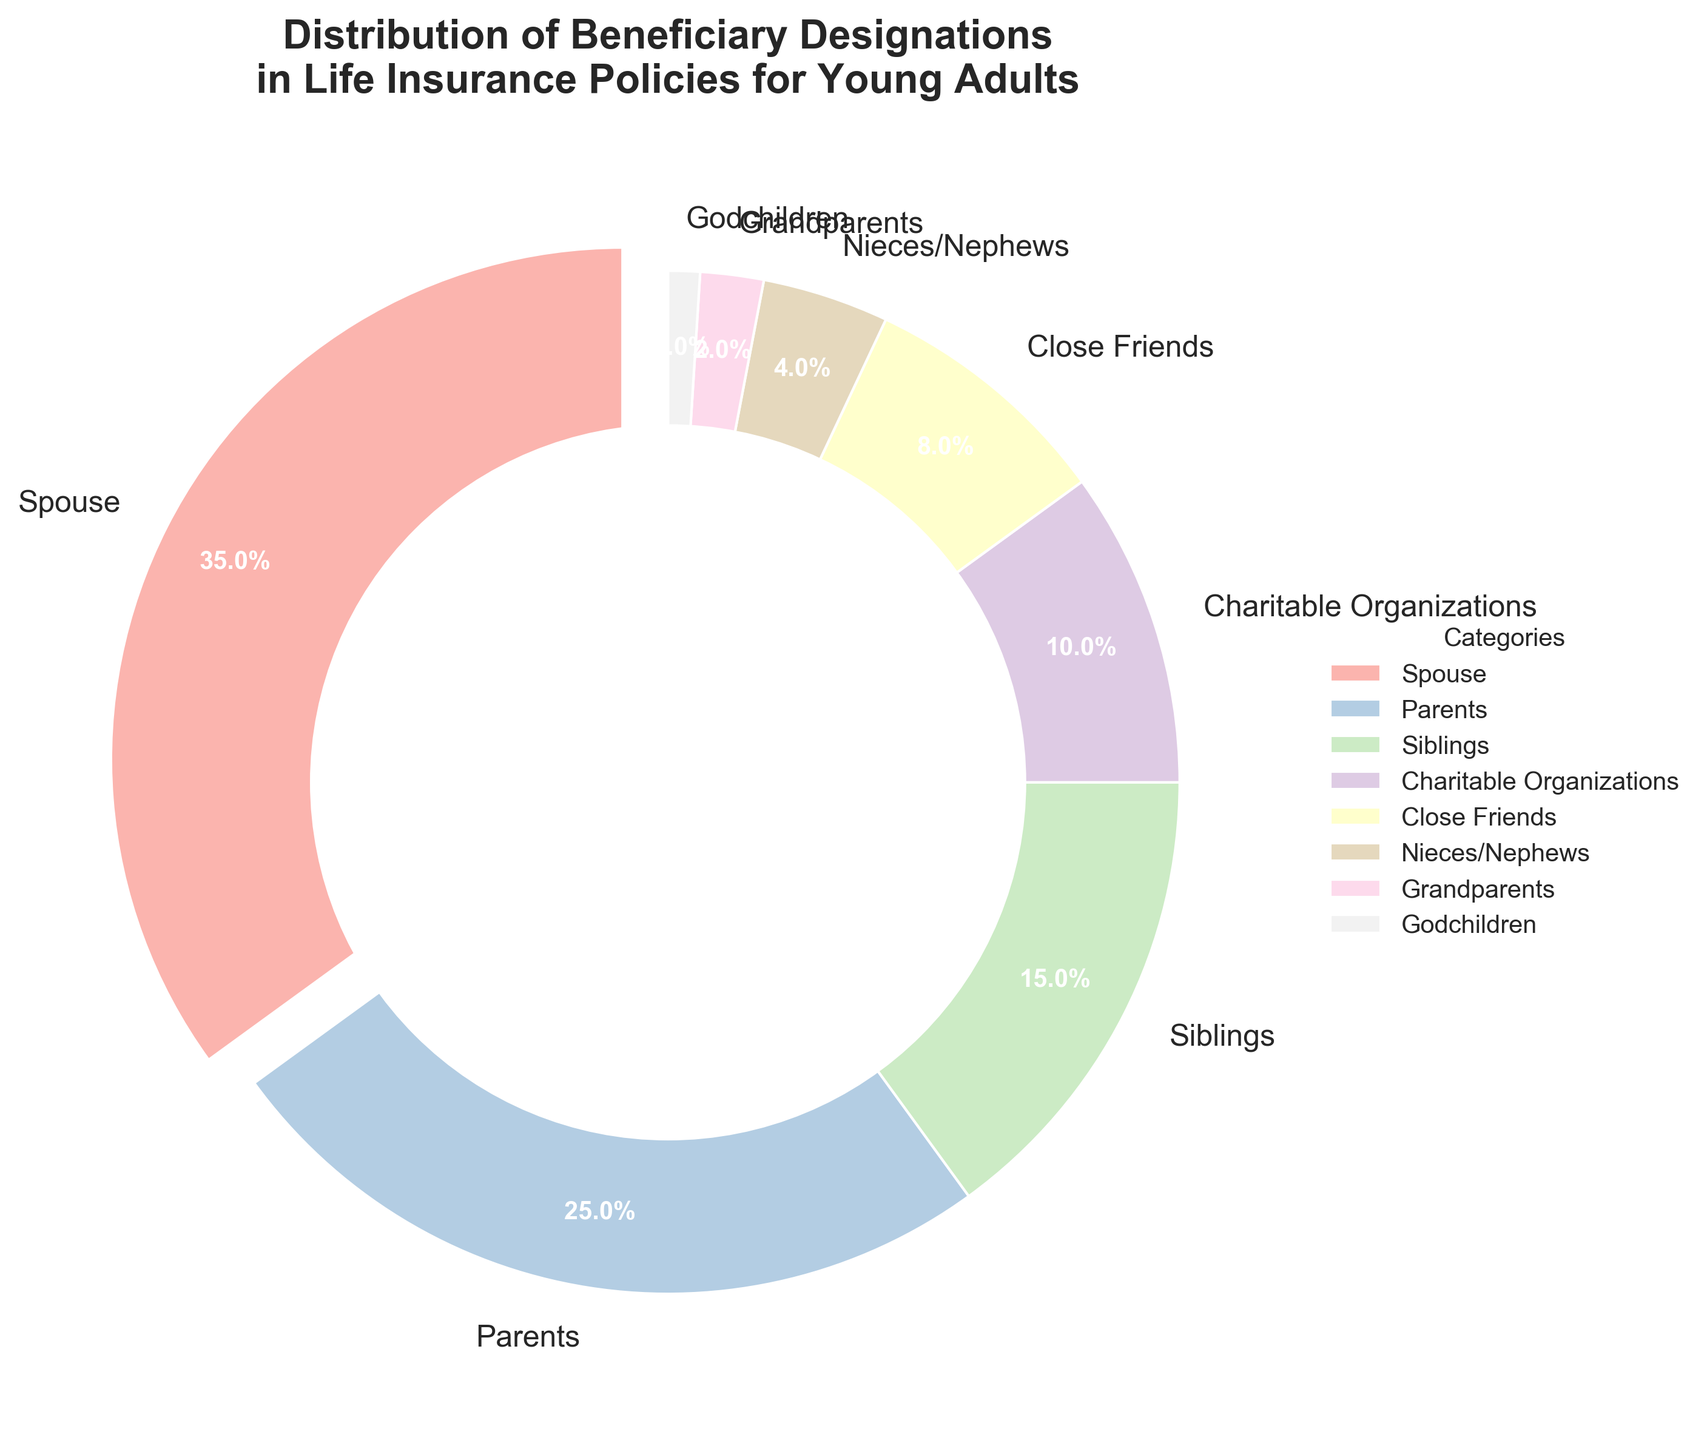What is the largest beneficiary designation category in the chart? The largest beneficiary category is the one with the highest percentage shown in the chart, which is the "Spouse" category with 35%.
Answer: Spouse Which category has a smaller percentage, Close Friends or Nieces/Nephews? To determine which category has a smaller percentage, we compare the percentage values. Close Friends have 8%, whereas Nieces/Nephews have only 4%. Therefore, Nieces/Nephews have a smaller percentage.
Answer: Nieces/Nephews How much higher is the percentage of Spouses compared to Parents? The percentage for Spouses is 35% and for Parents is 25%. Subtracting these two values gives 35% - 25% = 10%. So, the percentage for Spouses is 10% higher than for Parents.
Answer: 10% Which beneficiary categories combined make up exactly half of the total percentage? Adding up the percentages of Spouse (35%) and Parents (25%) gives 35% + 25% = 60%. This is more than half. Let's try Spouse (35%) and Siblings (15%): 35% + 15% = 50%. Therefore, Spouse and Siblings combined make up exactly 50%.
Answer: Spouse and Siblings What percentage of beneficiaries are grouped into family categories (Spouse, Parents, Siblings, Nieces/Nephews, Grandparents)? Summing up the percentages of Spouse (35%), Parents (25%), Siblings (15%), Nieces/Nephews (4%), and Grandparents (2%) gives 35% + 25% + 15% + 4% + 2% = 81%.
Answer: 81% Which category is represented by a section that is exploded or pulled out in the pie chart, and why? The exploded section is often used to highlight the largest category. In this chart, the Spouse category (35%) is the largest and therefore is the one that is exploded or pulled out.
Answer: Spouse What is the total combined percentage of beneficiaries designated to non-family categories (Charitable Organizations, Close Friends, Godchildren)? Adding the percentages of Charitable Organizations (10%), Close Friends (8%), and Godchildren (1%) gives a total of 10% + 8% + 1% = 19%.
Answer: 19% How much more is the percentage of parents compared to charitable organizations? The percentage for Parents is 25% and for Charitable Organizations is 10%. The difference is 25% - 10% = 15%.
Answer: 15% What is the percentage difference between the largest and smallest beneficiary designation categories? The largest category, Spouse, has 35%, and the smallest category, Godchildren, has 1%. So the difference is 35% - 1% = 34%.
Answer: 34% If you were to combine the percentages for siblings and grandparents, would it be greater than or less than the percentage for parents? The sum of the percentages for Siblings (15%) and Grandparents (2%) is 15% + 2% = 17%. This is less than the percentage for Parents, which is 25%.
Answer: Less than 